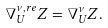Convert formula to latex. <formula><loc_0><loc_0><loc_500><loc_500>\nabla _ { U } ^ { \nu , r e } Z = \nabla _ { U } ^ { \nu } Z .</formula> 